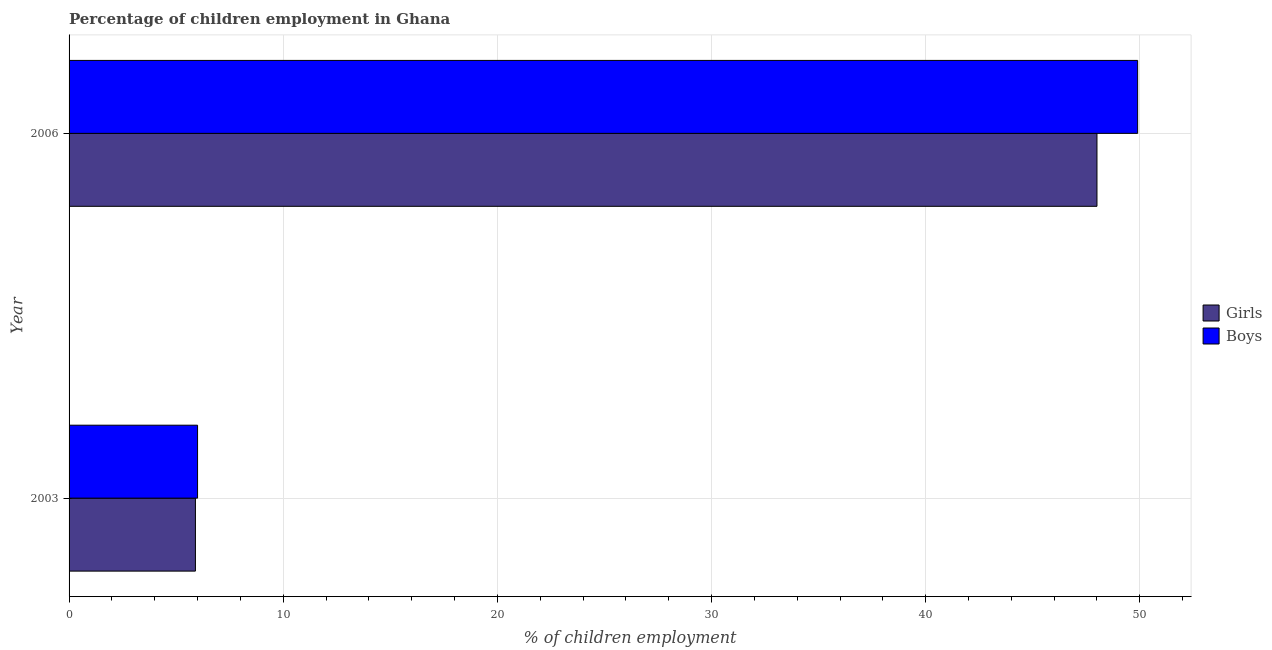How many groups of bars are there?
Your response must be concise. 2. Are the number of bars per tick equal to the number of legend labels?
Provide a succinct answer. Yes. What is the label of the 2nd group of bars from the top?
Your response must be concise. 2003. What is the percentage of employed girls in 2006?
Offer a terse response. 48. Across all years, what is the maximum percentage of employed boys?
Make the answer very short. 49.9. In which year was the percentage of employed girls maximum?
Provide a short and direct response. 2006. In which year was the percentage of employed boys minimum?
Your answer should be compact. 2003. What is the total percentage of employed girls in the graph?
Your answer should be very brief. 53.9. What is the difference between the percentage of employed boys in 2003 and that in 2006?
Provide a succinct answer. -43.9. What is the difference between the percentage of employed girls in 2003 and the percentage of employed boys in 2006?
Give a very brief answer. -44. What is the average percentage of employed girls per year?
Give a very brief answer. 26.95. In the year 2006, what is the difference between the percentage of employed boys and percentage of employed girls?
Your answer should be compact. 1.9. What is the ratio of the percentage of employed boys in 2003 to that in 2006?
Your answer should be compact. 0.12. Is the percentage of employed girls in 2003 less than that in 2006?
Make the answer very short. Yes. Is the difference between the percentage of employed girls in 2003 and 2006 greater than the difference between the percentage of employed boys in 2003 and 2006?
Offer a terse response. Yes. In how many years, is the percentage of employed girls greater than the average percentage of employed girls taken over all years?
Give a very brief answer. 1. What does the 1st bar from the top in 2006 represents?
Give a very brief answer. Boys. What does the 1st bar from the bottom in 2003 represents?
Your answer should be compact. Girls. How many years are there in the graph?
Make the answer very short. 2. What is the difference between two consecutive major ticks on the X-axis?
Offer a very short reply. 10. Are the values on the major ticks of X-axis written in scientific E-notation?
Your response must be concise. No. Does the graph contain grids?
Offer a terse response. Yes. How many legend labels are there?
Provide a succinct answer. 2. How are the legend labels stacked?
Offer a very short reply. Vertical. What is the title of the graph?
Make the answer very short. Percentage of children employment in Ghana. What is the label or title of the X-axis?
Make the answer very short. % of children employment. What is the label or title of the Y-axis?
Make the answer very short. Year. What is the % of children employment in Girls in 2003?
Offer a very short reply. 5.9. What is the % of children employment of Boys in 2003?
Keep it short and to the point. 6. What is the % of children employment of Boys in 2006?
Your answer should be compact. 49.9. Across all years, what is the maximum % of children employment in Girls?
Offer a terse response. 48. Across all years, what is the maximum % of children employment in Boys?
Give a very brief answer. 49.9. Across all years, what is the minimum % of children employment in Boys?
Your answer should be compact. 6. What is the total % of children employment of Girls in the graph?
Your response must be concise. 53.9. What is the total % of children employment in Boys in the graph?
Make the answer very short. 55.9. What is the difference between the % of children employment in Girls in 2003 and that in 2006?
Your answer should be compact. -42.1. What is the difference between the % of children employment of Boys in 2003 and that in 2006?
Give a very brief answer. -43.9. What is the difference between the % of children employment of Girls in 2003 and the % of children employment of Boys in 2006?
Provide a succinct answer. -44. What is the average % of children employment of Girls per year?
Keep it short and to the point. 26.95. What is the average % of children employment of Boys per year?
Offer a very short reply. 27.95. In the year 2003, what is the difference between the % of children employment of Girls and % of children employment of Boys?
Your answer should be compact. -0.1. What is the ratio of the % of children employment in Girls in 2003 to that in 2006?
Provide a short and direct response. 0.12. What is the ratio of the % of children employment of Boys in 2003 to that in 2006?
Offer a very short reply. 0.12. What is the difference between the highest and the second highest % of children employment of Girls?
Give a very brief answer. 42.1. What is the difference between the highest and the second highest % of children employment of Boys?
Offer a very short reply. 43.9. What is the difference between the highest and the lowest % of children employment in Girls?
Keep it short and to the point. 42.1. What is the difference between the highest and the lowest % of children employment of Boys?
Provide a succinct answer. 43.9. 